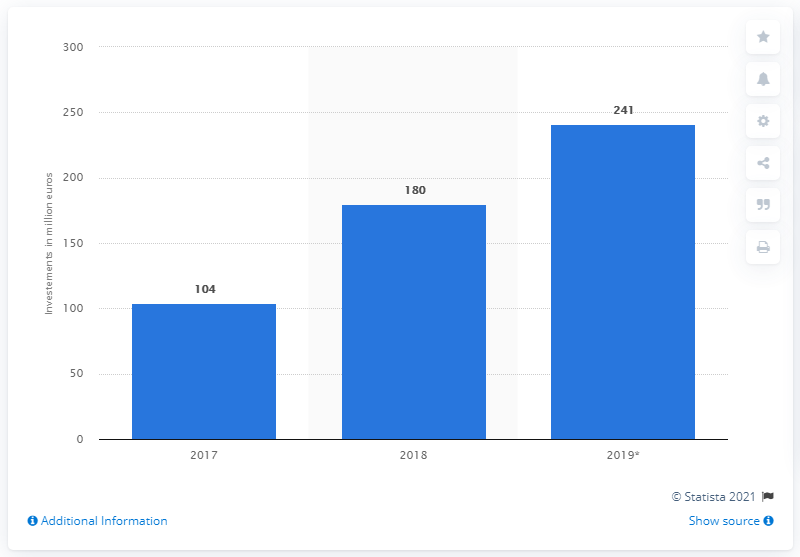Mention a couple of crucial points in this snapshot. In 2019, the influencer marketing sector was expected to receive an investment of approximately 241. In 2018, the investment in the influencer marketing sector reached 180 million. In 2017, Italy invested approximately $104 million in the influencer marketing sector. 